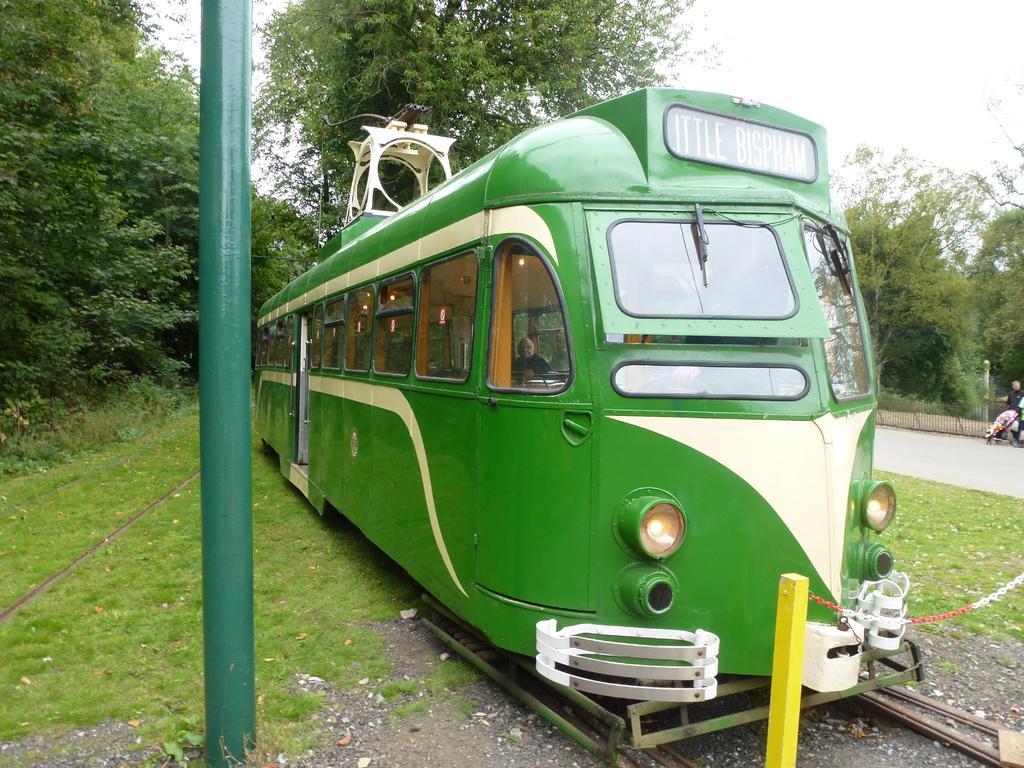Could you give a brief overview of what you see in this image? In this image a train is on the track. A person is inside the train. Left side there is a pole on the grassland. Right side there is a person and a baby trolley are on the road. Background there are few trees. Right top there is sky. Right bottom there is fence. 